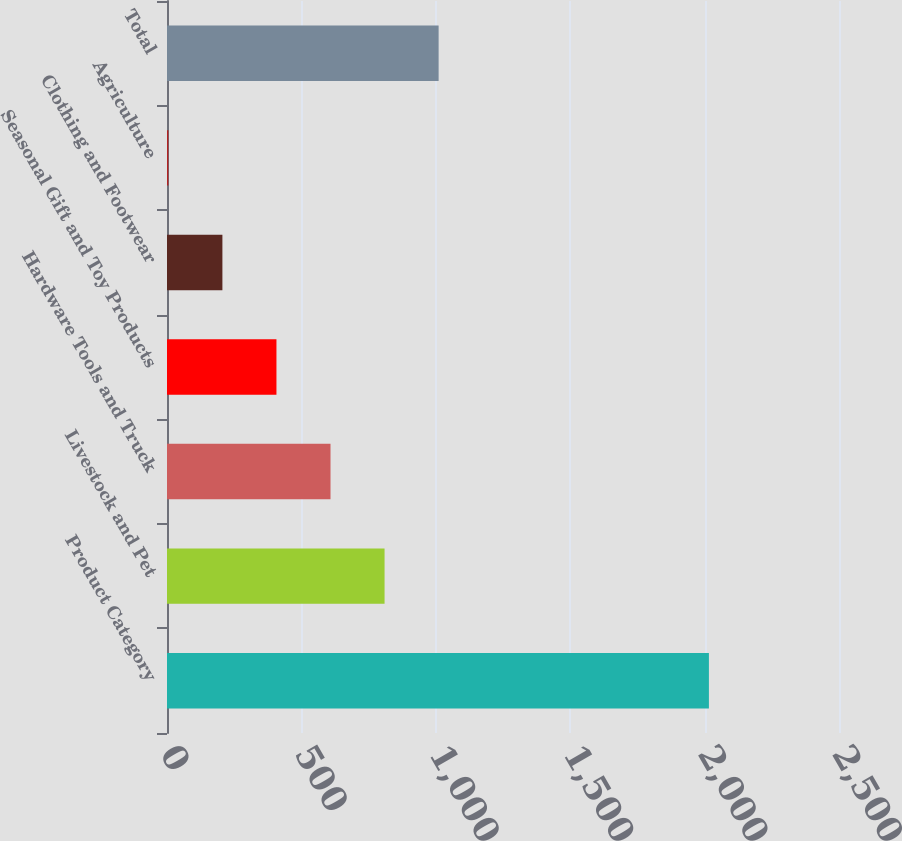Convert chart to OTSL. <chart><loc_0><loc_0><loc_500><loc_500><bar_chart><fcel>Product Category<fcel>Livestock and Pet<fcel>Hardware Tools and Truck<fcel>Seasonal Gift and Toy Products<fcel>Clothing and Footwear<fcel>Agriculture<fcel>Total<nl><fcel>2016<fcel>809.4<fcel>608.3<fcel>407.2<fcel>206.1<fcel>5<fcel>1010.5<nl></chart> 